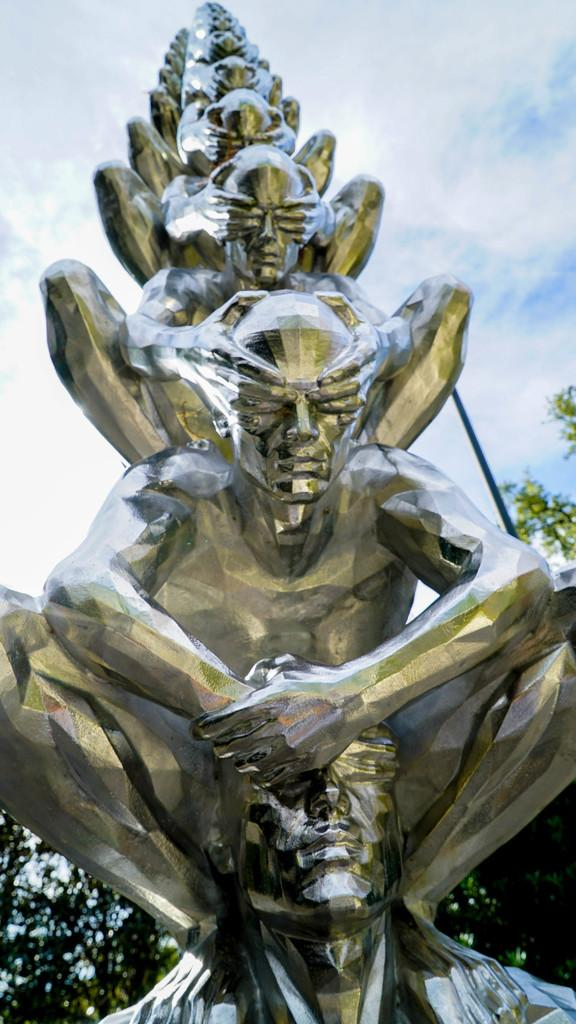What is the main subject in the image? There is a sculpture in the image. What color is the background of the image? The background of the image is white. What type of question is being asked by the sculpture in the image? There is no indication in the image that the sculpture is asking a question or capable of doing so. 